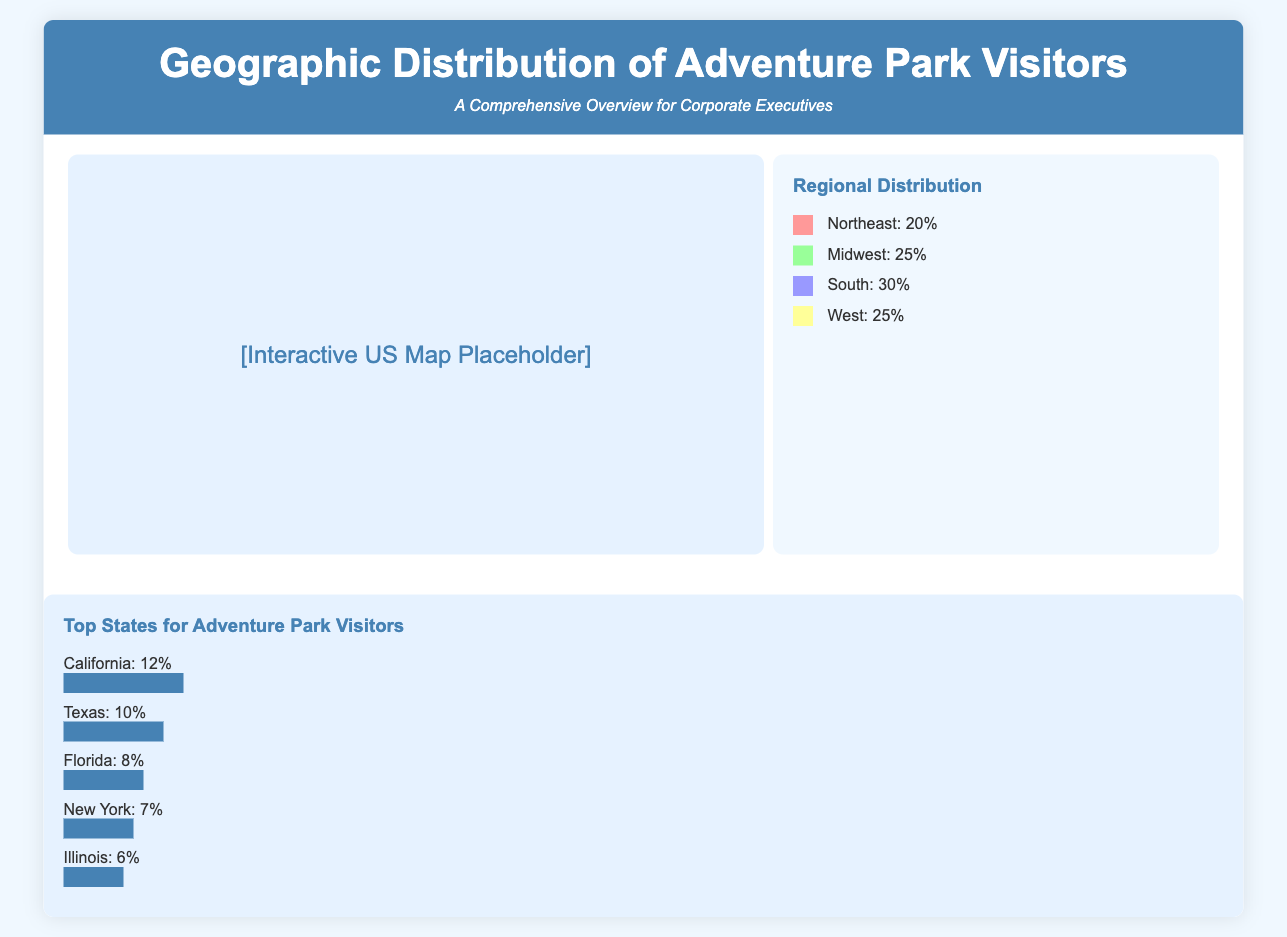What percentage of visitors come from the South? The infographic shows that 30% of adventure park visitors come from the South region.
Answer: 30% Which region has the highest percentage of visitors? The South region has the highest visitor percentage at 30%.
Answer: South What is the percentage of adventure park visitors from the Northeast? The document states that visitors from the Northeast region make up 20% of the total.
Answer: 20% Which state has the highest percentage of visitors? According to the top states section, California has the highest percentage of adventure park visitors at 12%.
Answer: California What is the percentage of visitors from Florida? The percentage of adventure park visitors from Florida is listed as 8%.
Answer: 8% If the Midwest and West percentages are combined, what is the total? The Midwest has 25% and the West has 25%, totaling 50% combined.
Answer: 50% In which region do visitors constitute 25%? Both the Midwest and West regions have 25% of visitors.
Answer: Midwest, West Which state has a visitor percentage of 6%? The state of Illinois has a listed visitor percentage of 6%.
Answer: Illinois 